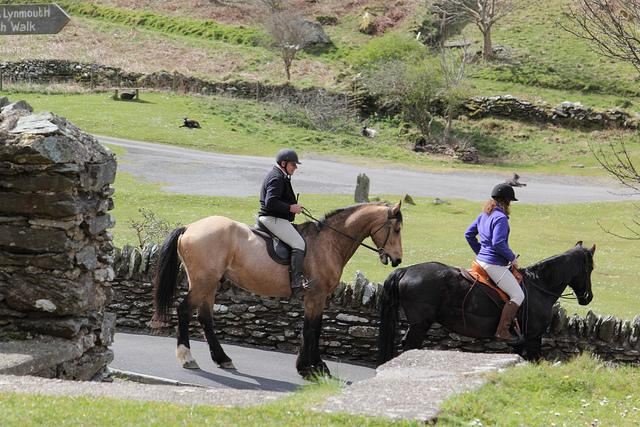What are the black helmets the people are wearing made for? protection 